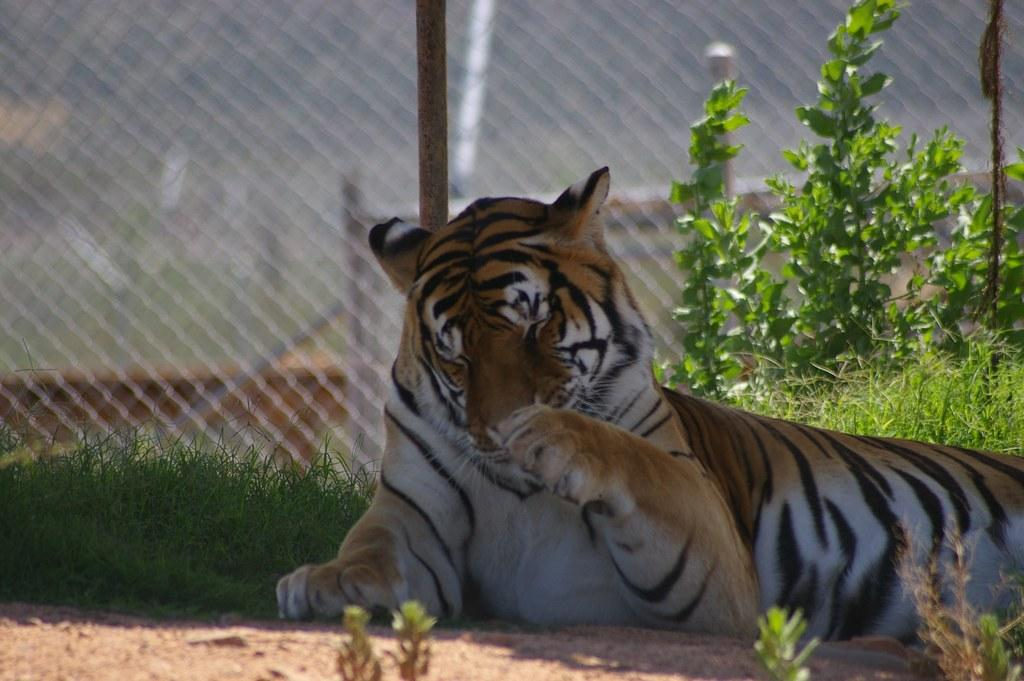What animal is lying on the ground in the image? There is a tiger lying on the ground in the image. What type of vegetation can be seen in the image? There is grass visible in the image, and small plants are present as well. How would you describe the background of the image? The background of the image is slightly blurred. What architectural feature can be seen in the background? There is a fence visible in the background of the image. How many turkeys are standing next to the tiger in the image? There are no turkeys present in the image; it only features a tiger lying on the ground. What part of the tiger's body is extended in the image? The image does not show any specific part of the tiger's body being extended. 